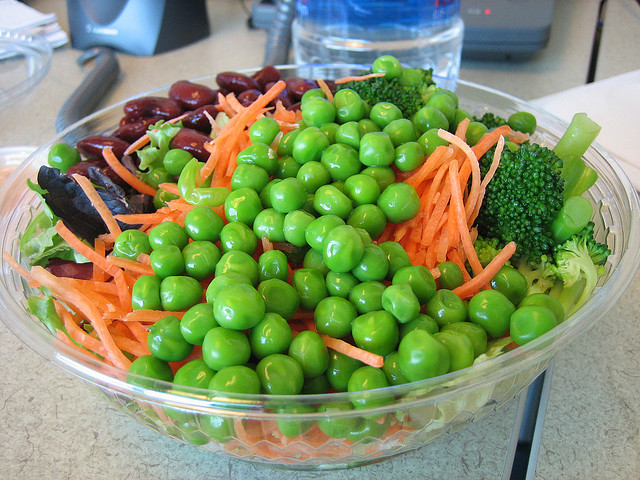How many bottles are in the photo? It appears there has been a misunderstanding, as there are no bottles visible in the photo. The photo actually shows a bowl filled with a variety of healthy foods, including green peas, carrots, broccoli, and red beans. 